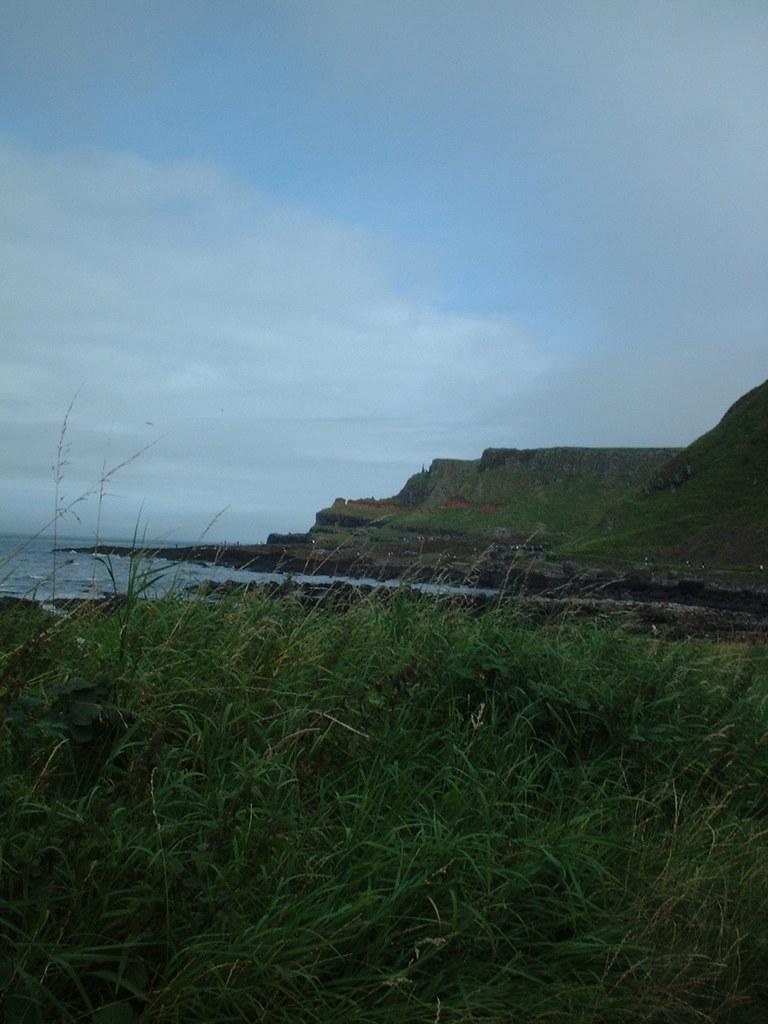What type of vegetation is at the bottom of the image? There are plants at the bottom of the image. What natural feature is depicted on the left side of the image? The image appears to depict a sea on the left side. What is visible at the top of the image? The sky is visible at the top of the image. How would you describe the weather in the image? The sky is cloudy, which suggests a partly cloudy or overcast day. What type of engine can be seen powering a boat in the image? There is no boat or engine present in the image; it features plants, a sea, and a cloudy sky. What kind of mist is visible in the image? There is no mist present in the image; it is a clear depiction of plants, a sea, and a cloudy sky. 